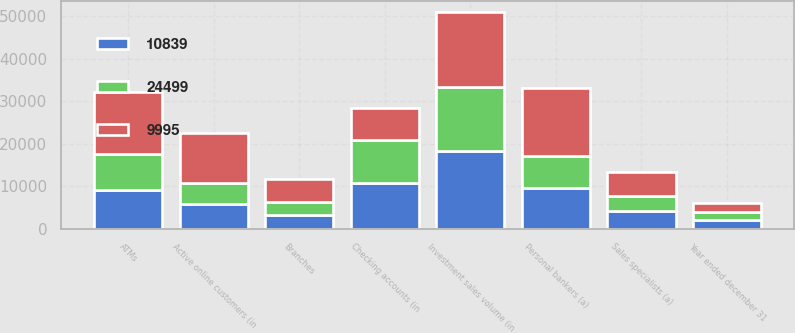Convert chart to OTSL. <chart><loc_0><loc_0><loc_500><loc_500><stacked_bar_chart><ecel><fcel>Year ended december 31<fcel>Investment sales volume (in<fcel>Branches<fcel>ATMs<fcel>Personal bankers (a)<fcel>Sales specialists (a)<fcel>Active online customers (in<fcel>Checking accounts (in<nl><fcel>9995<fcel>2008<fcel>17640<fcel>5474<fcel>14568<fcel>15825<fcel>5661<fcel>11710<fcel>7573<nl><fcel>10839<fcel>2007<fcel>18360<fcel>3152<fcel>9186<fcel>9650<fcel>4105<fcel>5918<fcel>10839<nl><fcel>24499<fcel>2006<fcel>14882<fcel>3079<fcel>8506<fcel>7573<fcel>3614<fcel>4909<fcel>9995<nl></chart> 